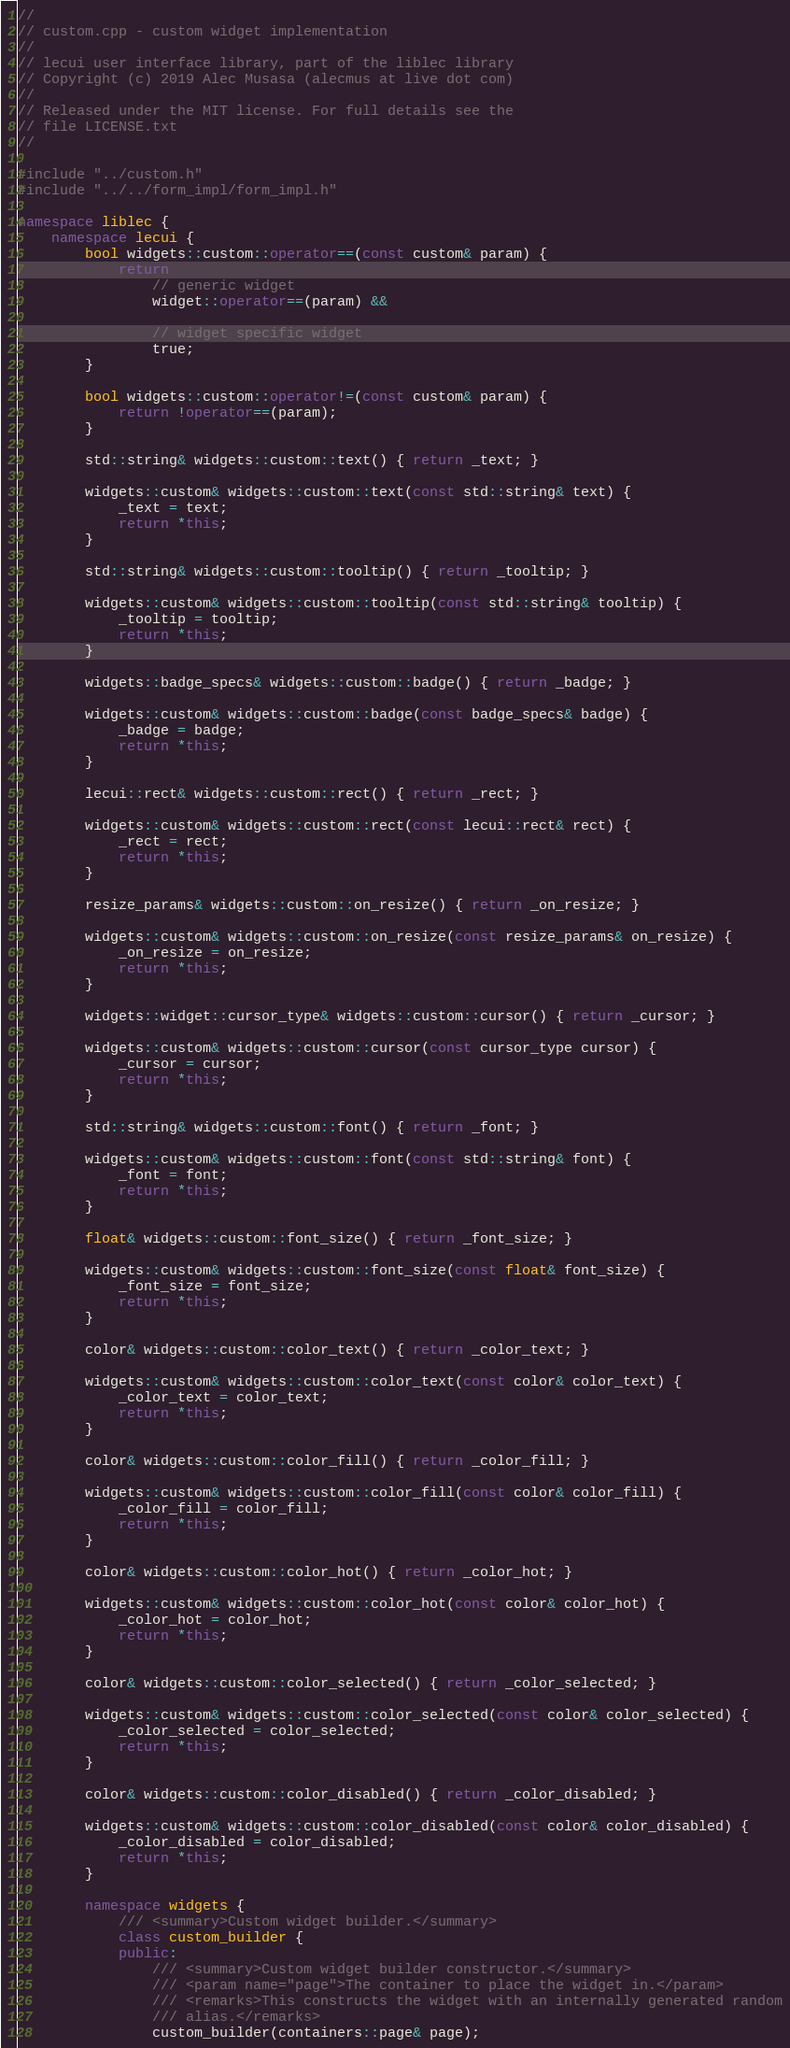<code> <loc_0><loc_0><loc_500><loc_500><_C++_>//
// custom.cpp - custom widget implementation
//
// lecui user interface library, part of the liblec library
// Copyright (c) 2019 Alec Musasa (alecmus at live dot com)
//
// Released under the MIT license. For full details see the
// file LICENSE.txt
//

#include "../custom.h"
#include "../../form_impl/form_impl.h"

namespace liblec {
	namespace lecui {
		bool widgets::custom::operator==(const custom& param) {
			return
				// generic widget
				widget::operator==(param) &&

				// widget specific widget
				true;
		}

		bool widgets::custom::operator!=(const custom& param) {
			return !operator==(param);
		}

		std::string& widgets::custom::text() { return _text; }

		widgets::custom& widgets::custom::text(const std::string& text) {
			_text = text;
			return *this;
		}

		std::string& widgets::custom::tooltip() { return _tooltip; }

		widgets::custom& widgets::custom::tooltip(const std::string& tooltip) {
			_tooltip = tooltip;
			return *this;
		}

		widgets::badge_specs& widgets::custom::badge() { return _badge; }

		widgets::custom& widgets::custom::badge(const badge_specs& badge) {
			_badge = badge;
			return *this;
		}

		lecui::rect& widgets::custom::rect() { return _rect; }

		widgets::custom& widgets::custom::rect(const lecui::rect& rect) {
			_rect = rect;
			return *this;
		}

		resize_params& widgets::custom::on_resize() { return _on_resize; }

		widgets::custom& widgets::custom::on_resize(const resize_params& on_resize) {
			_on_resize = on_resize;
			return *this;
		}

		widgets::widget::cursor_type& widgets::custom::cursor() { return _cursor; }

		widgets::custom& widgets::custom::cursor(const cursor_type cursor) {
			_cursor = cursor;
			return *this;
		}

		std::string& widgets::custom::font() { return _font; }

		widgets::custom& widgets::custom::font(const std::string& font) {
			_font = font;
			return *this;
		}

		float& widgets::custom::font_size() { return _font_size; }

		widgets::custom& widgets::custom::font_size(const float& font_size) {
			_font_size = font_size;
			return *this;
		}

		color& widgets::custom::color_text() { return _color_text; }

		widgets::custom& widgets::custom::color_text(const color& color_text) {
			_color_text = color_text;
			return *this;
		}

		color& widgets::custom::color_fill() { return _color_fill; }

		widgets::custom& widgets::custom::color_fill(const color& color_fill) {
			_color_fill = color_fill;
			return *this;
		}

		color& widgets::custom::color_hot() { return _color_hot; }

		widgets::custom& widgets::custom::color_hot(const color& color_hot) {
			_color_hot = color_hot;
			return *this;
		}

		color& widgets::custom::color_selected() { return _color_selected; }

		widgets::custom& widgets::custom::color_selected(const color& color_selected) {
			_color_selected = color_selected;
			return *this;
		}

		color& widgets::custom::color_disabled() { return _color_disabled; }

		widgets::custom& widgets::custom::color_disabled(const color& color_disabled) {
			_color_disabled = color_disabled;
			return *this;
		}

		namespace widgets {
			/// <summary>Custom widget builder.</summary>
			class custom_builder {
			public:
				/// <summary>Custom widget builder constructor.</summary>
				/// <param name="page">The container to place the widget in.</param>
				/// <remarks>This constructs the widget with an internally generated random
				/// alias.</remarks>
				custom_builder(containers::page& page);
</code> 